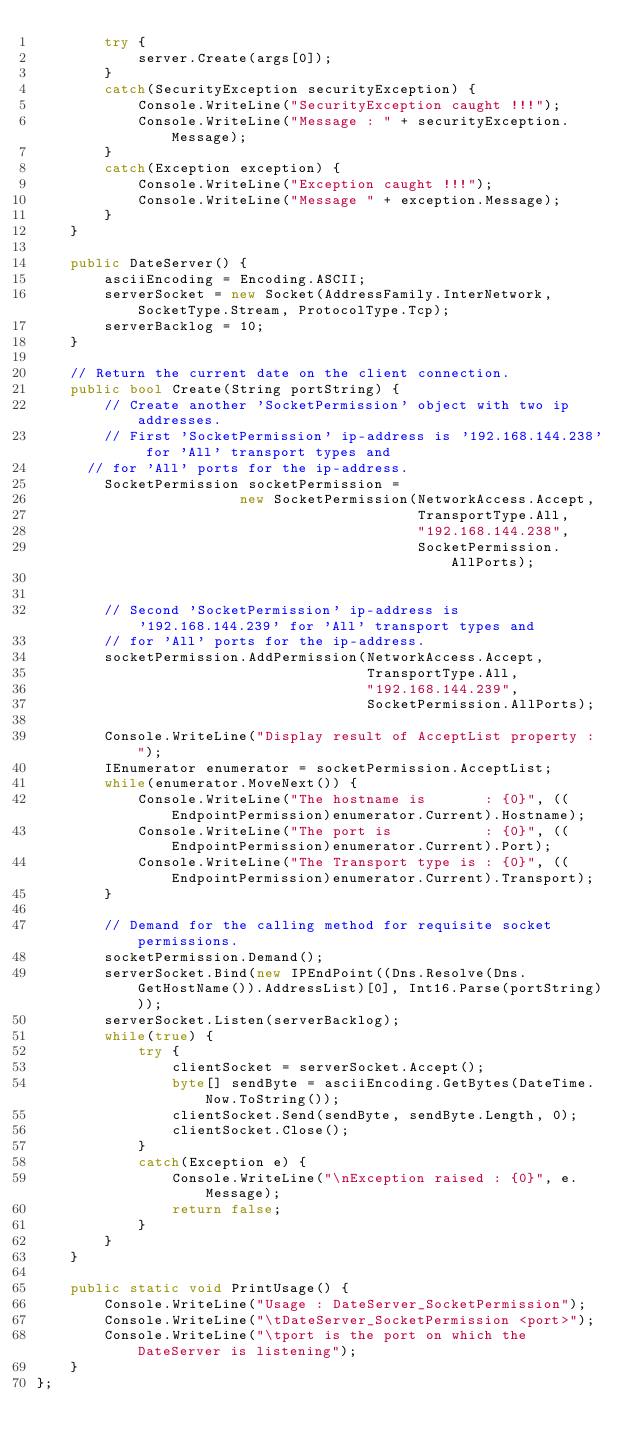<code> <loc_0><loc_0><loc_500><loc_500><_C#_>		try {
			server.Create(args[0]);
		}
		catch(SecurityException securityException) {
			Console.WriteLine("SecurityException caught !!!");
			Console.WriteLine("Message : " + securityException.Message);
		}
		catch(Exception exception) {
			Console.WriteLine("Exception caught !!!");
			Console.WriteLine("Message " + exception.Message);
		}
	}

	public DateServer() {
		asciiEncoding = Encoding.ASCII;
		serverSocket = new Socket(AddressFamily.InterNetwork, SocketType.Stream, ProtocolType.Tcp);
		serverBacklog = 10;
	}

	// Return the current date on the client connection.
	public bool Create(String portString) {
		// Create another 'SocketPermission' object with two ip addresses.
		// First 'SocketPermission' ip-address is '192.168.144.238' for 'All' transport types and
      // for 'All' ports for the ip-address.
		SocketPermission socketPermission = 
						new SocketPermission(NetworkAccess.Accept,
											 TransportType.All,
											 "192.168.144.238",
											 SocketPermission.AllPorts);


        // Second 'SocketPermission' ip-address is '192.168.144.239' for 'All' transport types and 
        // for 'All' ports for the ip-address.
		socketPermission.AddPermission(NetworkAccess.Accept,
									   TransportType.All,
									   "192.168.144.239",
									   SocketPermission.AllPorts);

		Console.WriteLine("Display result of AcceptList property : ");
		IEnumerator enumerator = socketPermission.AcceptList;
		while(enumerator.MoveNext()) {
			Console.WriteLine("The hostname is       : {0}", ((EndpointPermission)enumerator.Current).Hostname);
			Console.WriteLine("The port is           : {0}", ((EndpointPermission)enumerator.Current).Port);
			Console.WriteLine("The Transport type is : {0}", ((EndpointPermission)enumerator.Current).Transport);
		}

		// Demand for the calling method for requisite socket permissions.
		socketPermission.Demand();
		serverSocket.Bind(new IPEndPoint((Dns.Resolve(Dns.GetHostName()).AddressList)[0], Int16.Parse(portString)));
		serverSocket.Listen(serverBacklog);
		while(true) {
			try {
				clientSocket = serverSocket.Accept();
				byte[] sendByte = asciiEncoding.GetBytes(DateTime.Now.ToString());
				clientSocket.Send(sendByte, sendByte.Length, 0);
				clientSocket.Close();
			}
			catch(Exception e) {
				Console.WriteLine("\nException raised : {0}", e.Message);
				return false;
			}
		}
	}

	public static void PrintUsage() {
		Console.WriteLine("Usage : DateServer_SocketPermission");
		Console.WriteLine("\tDateServer_SocketPermission <port>");
		Console.WriteLine("\tport is the port on which the DateServer is listening");
	}
};
</code> 